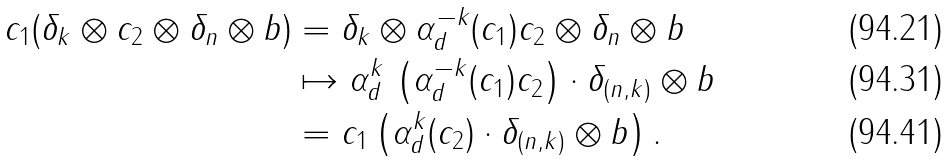<formula> <loc_0><loc_0><loc_500><loc_500>c _ { 1 } ( \delta _ { k } \otimes c _ { 2 } \otimes \delta _ { n } \otimes b ) & = \delta _ { k } \otimes \alpha _ { d } ^ { - k } ( c _ { 1 } ) c _ { 2 } \otimes \delta _ { n } \otimes b \\ & \mapsto \alpha _ { d } ^ { k } \, \left ( \alpha _ { d } ^ { - k } ( c _ { 1 } ) c _ { 2 } \right ) \cdot \delta _ { ( n , k ) } \otimes b \\ & = c _ { 1 } \left ( \alpha _ { d } ^ { k } ( c _ { 2 } ) \cdot \delta _ { ( n , k ) } \otimes b \right ) .</formula> 